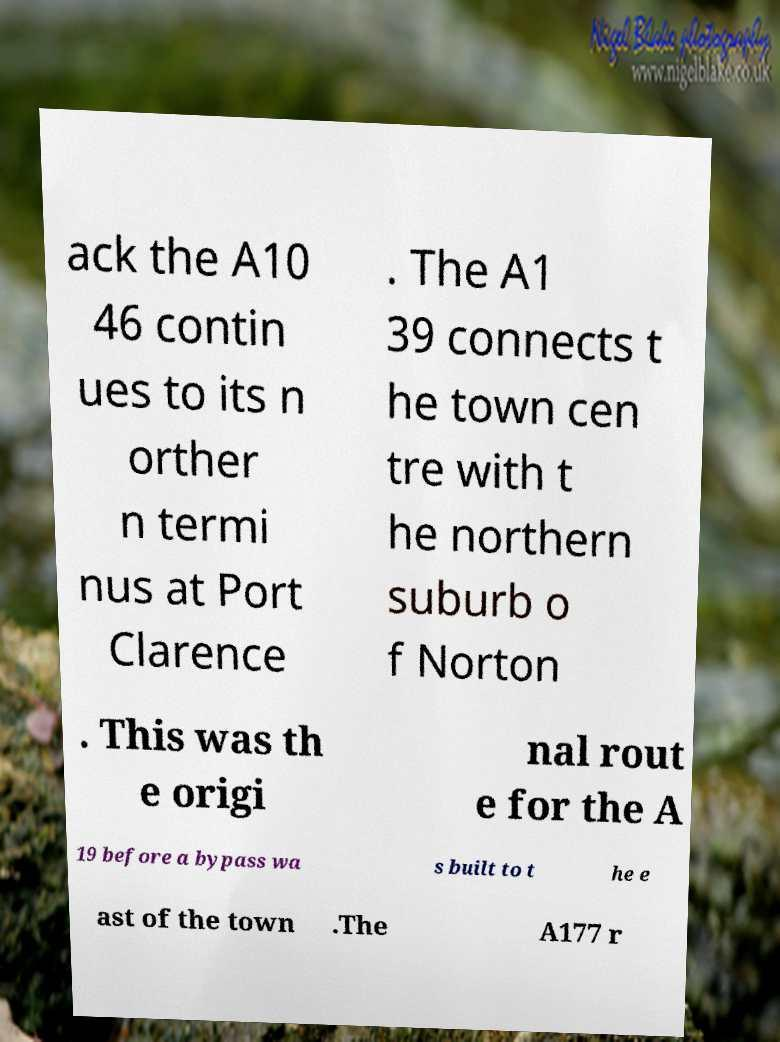I need the written content from this picture converted into text. Can you do that? ack the A10 46 contin ues to its n orther n termi nus at Port Clarence . The A1 39 connects t he town cen tre with t he northern suburb o f Norton . This was th e origi nal rout e for the A 19 before a bypass wa s built to t he e ast of the town .The A177 r 